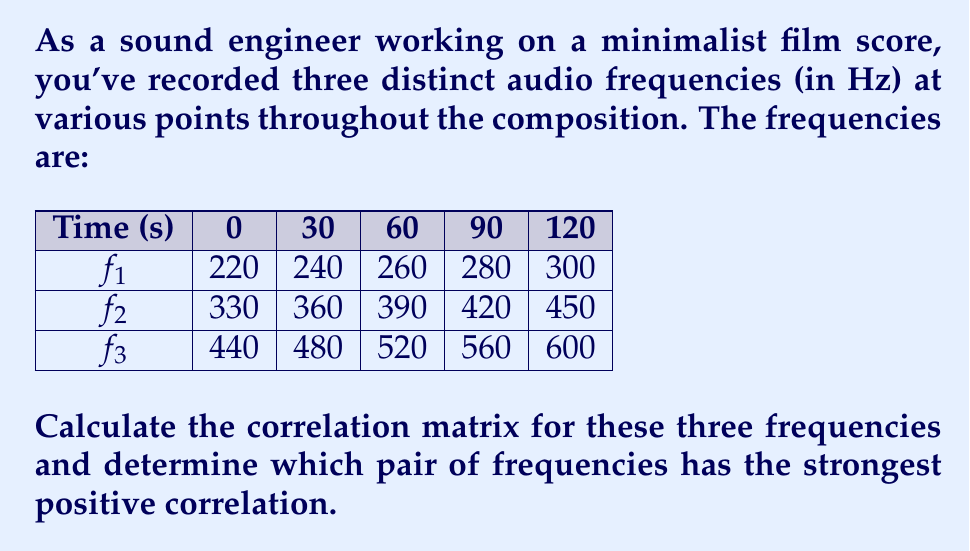Give your solution to this math problem. To solve this problem, we'll follow these steps:

1) First, we need to calculate the correlation coefficient for each pair of frequencies. The correlation coefficient is given by the formula:

   $$r = \frac{\sum_{i=1}^n (x_i - \bar{x})(y_i - \bar{y})}{\sqrt{\sum_{i=1}^n (x_i - \bar{x})^2 \sum_{i=1}^n (y_i - \bar{y})^2}}$$

2) Let's start by calculating the means for each frequency:
   
   $\bar{f_1} = \frac{220 + 240 + 260 + 280 + 300}{5} = 260$
   $\bar{f_2} = \frac{330 + 360 + 390 + 420 + 450}{5} = 390$
   $\bar{f_3} = \frac{440 + 480 + 520 + 560 + 600}{5} = 520$

3) Now, let's calculate the correlation between $f_1$ and $f_2$:

   $$r_{12} = \frac{(-40 \cdot -60) + (-20 \cdot -30) + (0 \cdot 0) + (20 \cdot 30) + (40 \cdot 60)}{\sqrt{(-40^2 + -20^2 + 0^2 + 20^2 + 40^2)(-60^2 + -30^2 + 0^2 + 30^2 + 60^2)}}$$

   $$r_{12} = \frac{2400 + 600 + 0 + 600 + 2400}{\sqrt{4000 \cdot 9000}} = \frac{6000}{6000} = 1$$

4) Similarly, we can calculate $r_{13}$ and $r_{23}$:

   $r_{13} = 1$
   $r_{23} = 1$

5) The correlation matrix is therefore:

   $$
   \begin{pmatrix}
   1 & 1 & 1 \\
   1 & 1 & 1 \\
   1 & 1 & 1
   \end{pmatrix}
   $$

6) All pairs of frequencies have a perfect positive correlation of 1.
Answer: All pairs have correlation 1; any pair has strongest positive correlation. 